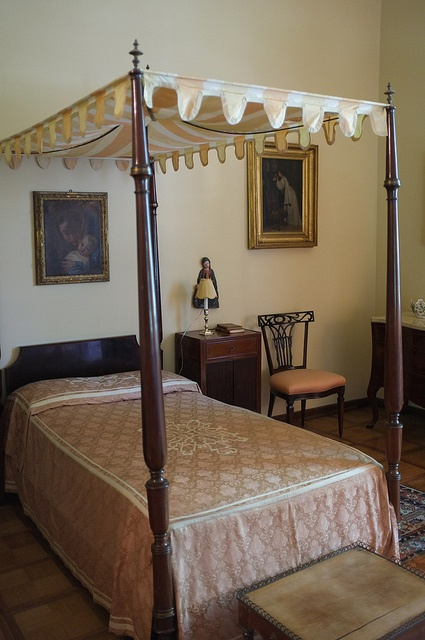Describe the objects in this image and their specific colors. I can see bed in gray, black, darkgray, and maroon tones and chair in gray, black, brown, and maroon tones in this image. 